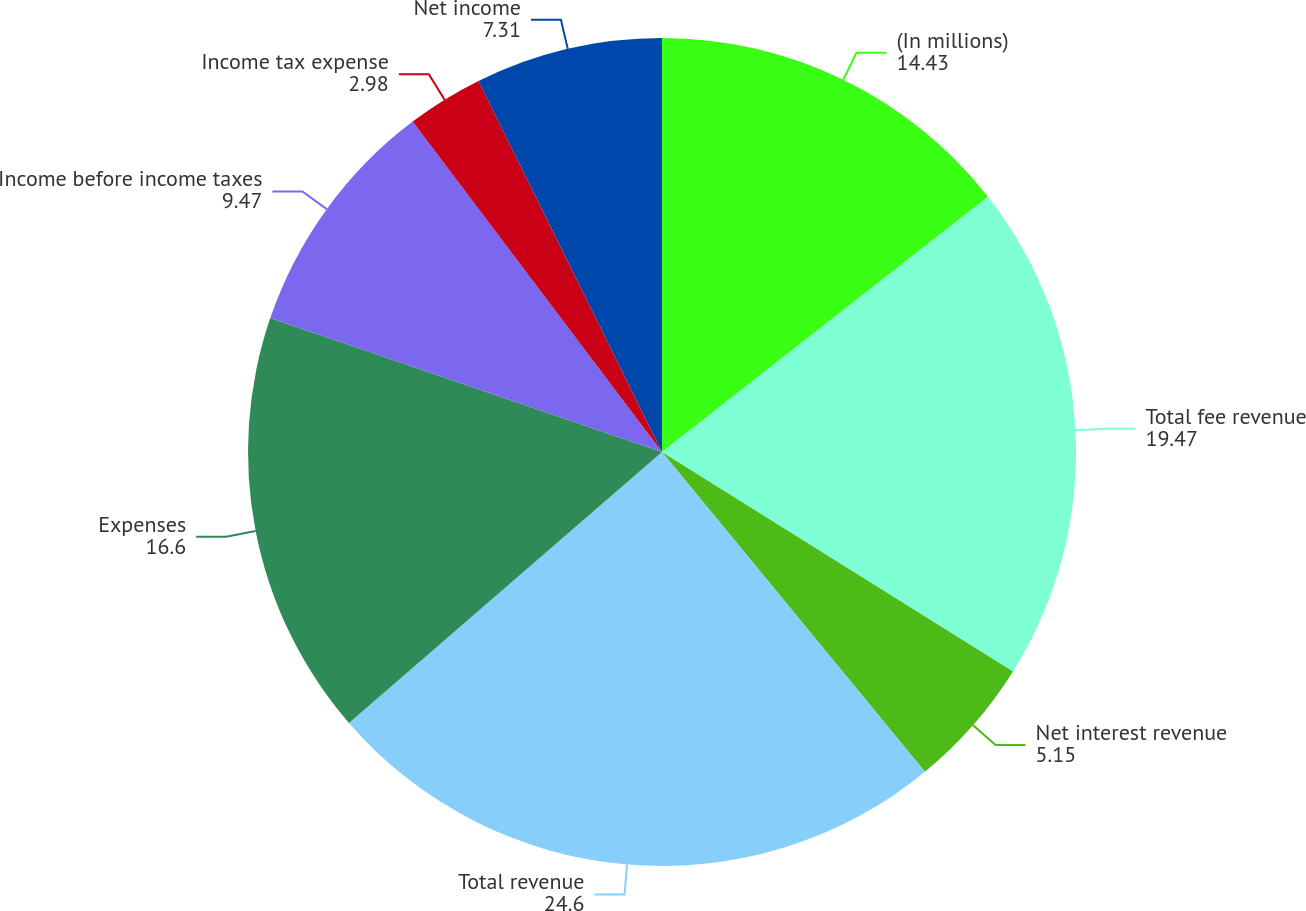Convert chart. <chart><loc_0><loc_0><loc_500><loc_500><pie_chart><fcel>(In millions)<fcel>Total fee revenue<fcel>Net interest revenue<fcel>Total revenue<fcel>Expenses<fcel>Income before income taxes<fcel>Income tax expense<fcel>Net income<nl><fcel>14.43%<fcel>19.47%<fcel>5.15%<fcel>24.6%<fcel>16.6%<fcel>9.47%<fcel>2.98%<fcel>7.31%<nl></chart> 